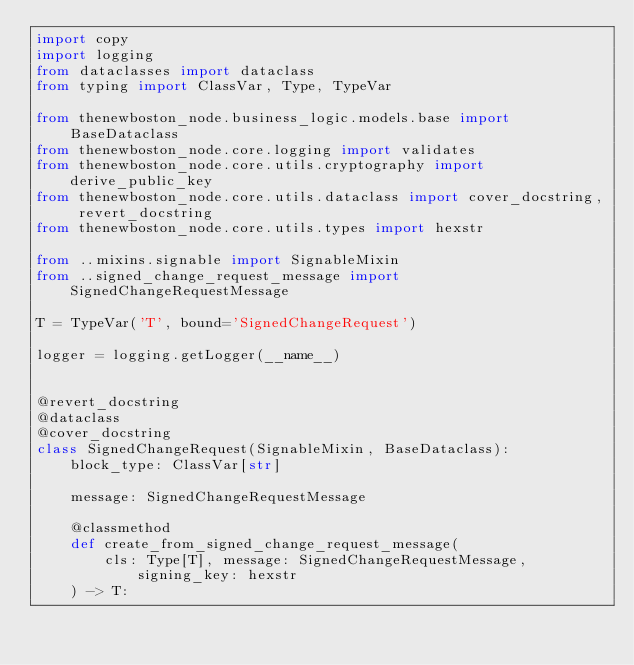Convert code to text. <code><loc_0><loc_0><loc_500><loc_500><_Python_>import copy
import logging
from dataclasses import dataclass
from typing import ClassVar, Type, TypeVar

from thenewboston_node.business_logic.models.base import BaseDataclass
from thenewboston_node.core.logging import validates
from thenewboston_node.core.utils.cryptography import derive_public_key
from thenewboston_node.core.utils.dataclass import cover_docstring, revert_docstring
from thenewboston_node.core.utils.types import hexstr

from ..mixins.signable import SignableMixin
from ..signed_change_request_message import SignedChangeRequestMessage

T = TypeVar('T', bound='SignedChangeRequest')

logger = logging.getLogger(__name__)


@revert_docstring
@dataclass
@cover_docstring
class SignedChangeRequest(SignableMixin, BaseDataclass):
    block_type: ClassVar[str]

    message: SignedChangeRequestMessage

    @classmethod
    def create_from_signed_change_request_message(
        cls: Type[T], message: SignedChangeRequestMessage, signing_key: hexstr
    ) -> T:</code> 